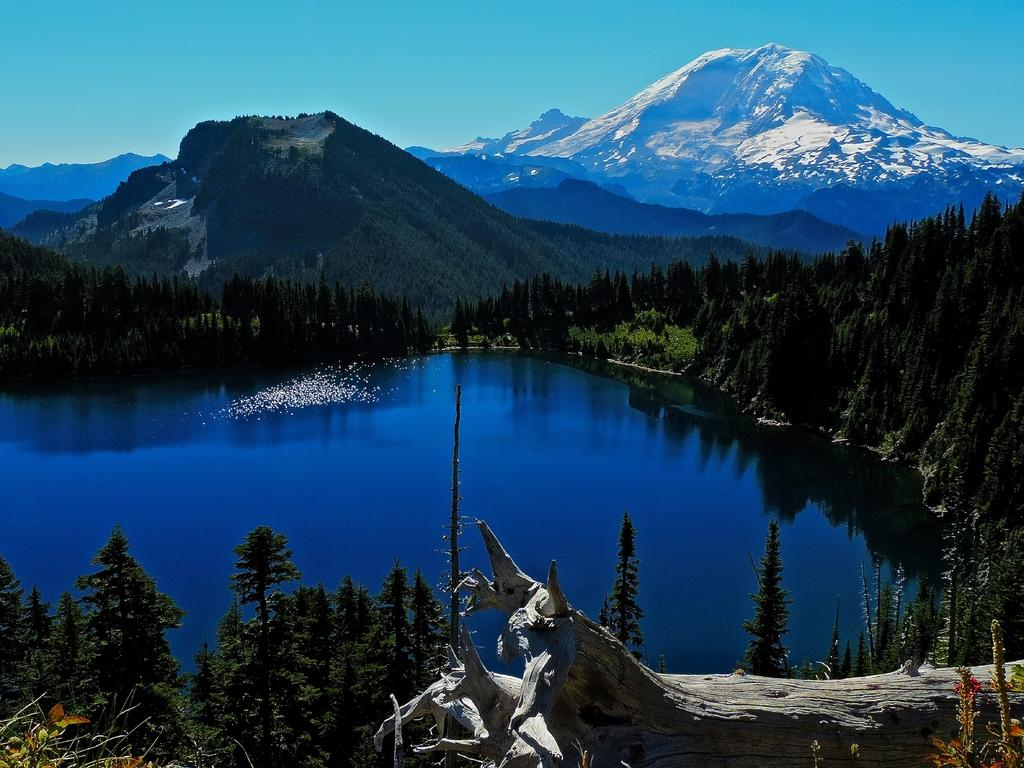What type of natural environment is depicted in the image? The image features many trees, a lake, and mountains in the background, indicating a natural environment. Can you describe the water body in the image? There is a lake in the image. What part of the tree can be seen in the image? There is a tree trunk in the image. What is visible in the background of the image? Mountains are visible in the background of the image. What is the condition of the sky in the image? The sky is clear and visible at the top of the image. What type of print can be seen on the apple in the image? There is no apple present in the image, so there is no print to observe. 